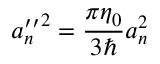<formula> <loc_0><loc_0><loc_500><loc_500>{ a _ { n } ^ { \prime \prime } } ^ { 2 } = \frac { \pi \eta _ { 0 } } { 3 } a _ { n } ^ { 2 }</formula> 